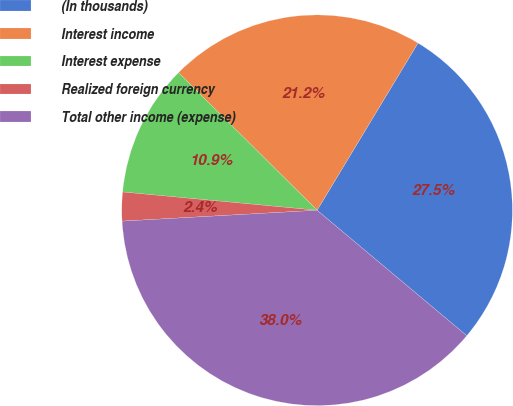<chart> <loc_0><loc_0><loc_500><loc_500><pie_chart><fcel>(In thousands)<fcel>Interest income<fcel>Interest expense<fcel>Realized foreign currency<fcel>Total other income (expense)<nl><fcel>27.46%<fcel>21.2%<fcel>10.95%<fcel>2.38%<fcel>38.01%<nl></chart> 